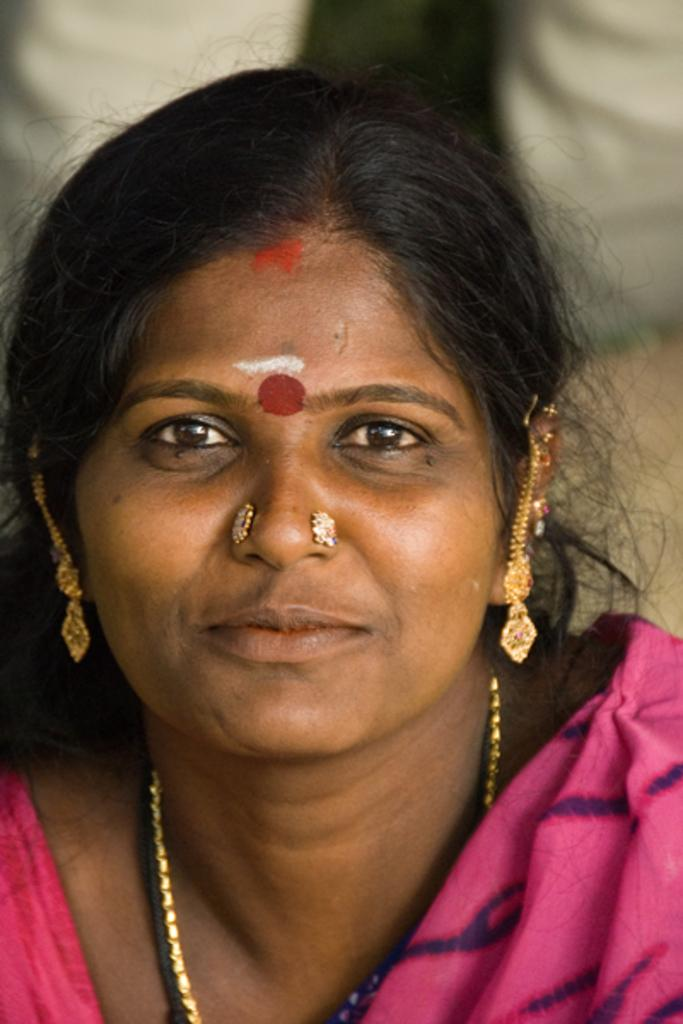What is the main subject in the foreground of the image? There is a woman in the foreground of the image. What is the woman wearing in the image? The woman is wearing ornaments in the image. Can you describe the background of the image? The background of the image is blurry. What type of lumber is being used to build the structure in the background of the image? There is no structure or lumber present in the background of the image; it is blurry. Is the woman running in the image? There is no indication that the woman is running in the image; she is simply standing in the foreground. 